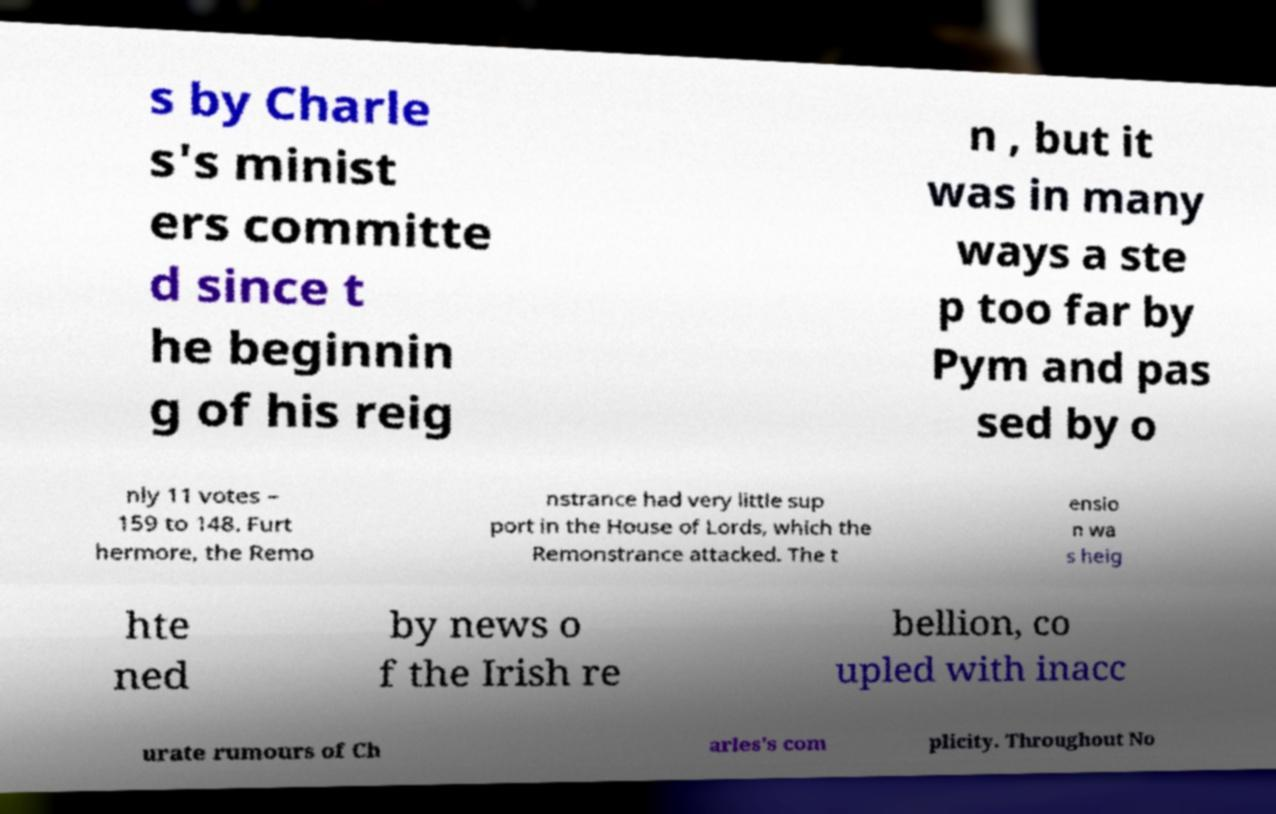Can you read and provide the text displayed in the image?This photo seems to have some interesting text. Can you extract and type it out for me? s by Charle s's minist ers committe d since t he beginnin g of his reig n , but it was in many ways a ste p too far by Pym and pas sed by o nly 11 votes – 159 to 148. Furt hermore, the Remo nstrance had very little sup port in the House of Lords, which the Remonstrance attacked. The t ensio n wa s heig hte ned by news o f the Irish re bellion, co upled with inacc urate rumours of Ch arles's com plicity. Throughout No 